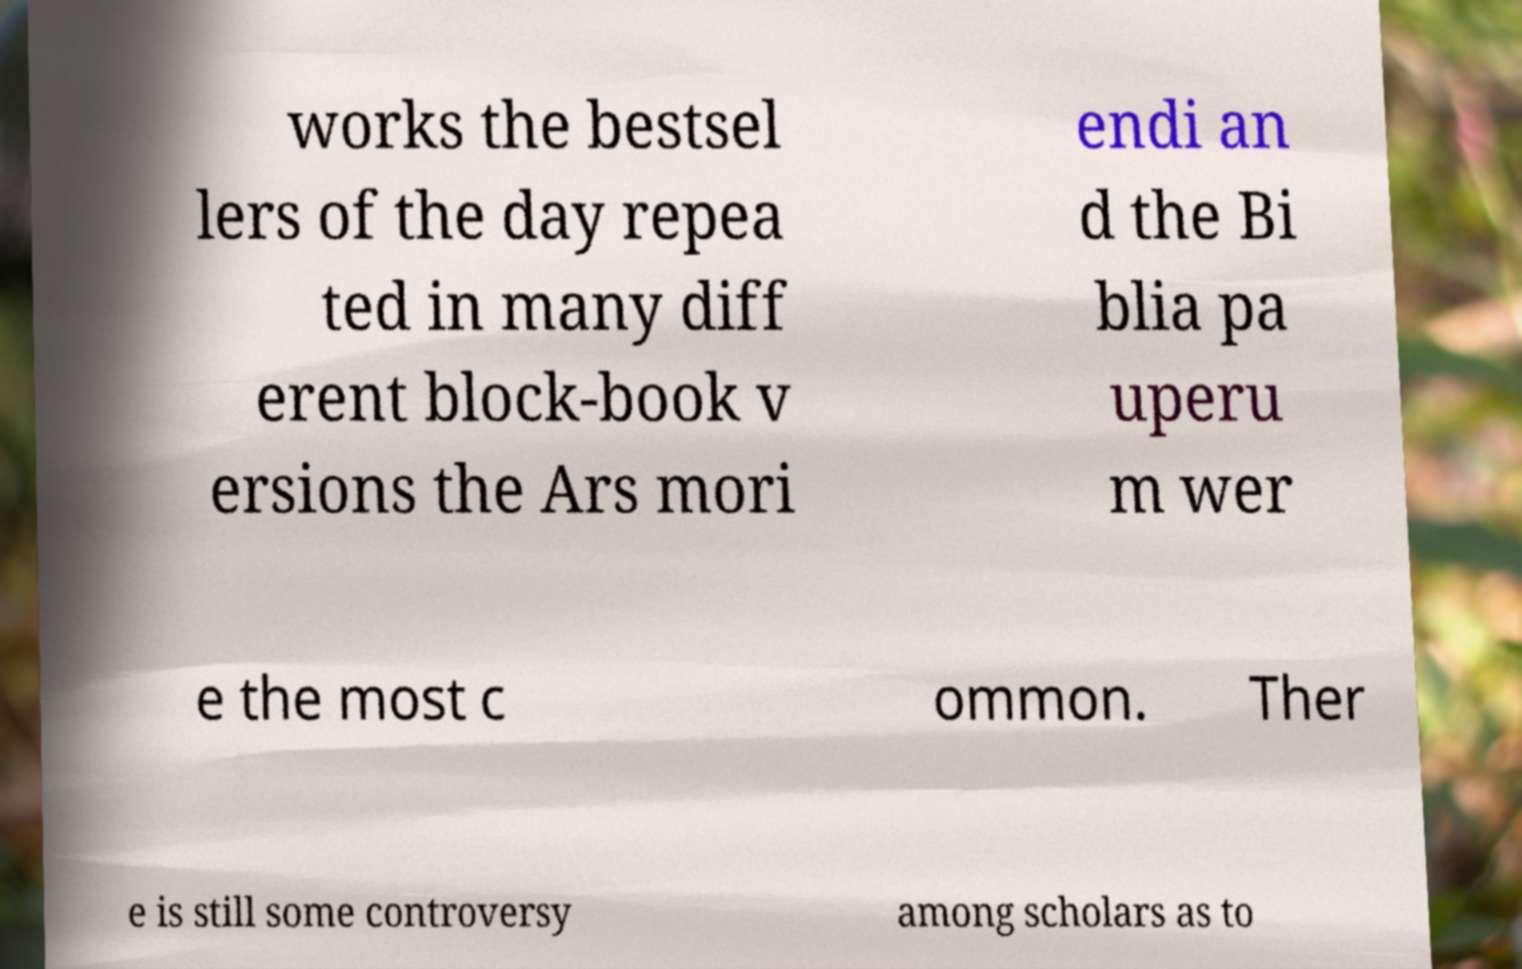There's text embedded in this image that I need extracted. Can you transcribe it verbatim? works the bestsel lers of the day repea ted in many diff erent block-book v ersions the Ars mori endi an d the Bi blia pa uperu m wer e the most c ommon. Ther e is still some controversy among scholars as to 